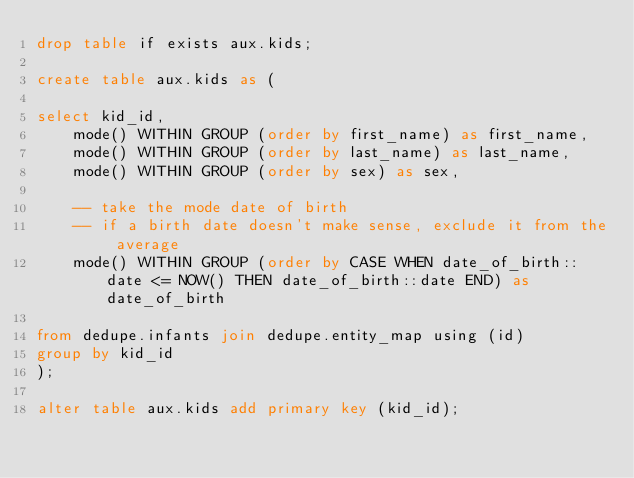Convert code to text. <code><loc_0><loc_0><loc_500><loc_500><_SQL_>drop table if exists aux.kids;

create table aux.kids as (

select kid_id, 
    mode() WITHIN GROUP (order by first_name) as first_name, 
    mode() WITHIN GROUP (order by last_name) as last_name,
    mode() WITHIN GROUP (order by sex) as sex,

    -- take the mode date of birth
    -- if a birth date doesn't make sense, exclude it from the average
    mode() WITHIN GROUP (order by CASE WHEN date_of_birth::date <= NOW() THEN date_of_birth::date END) as date_of_birth

from dedupe.infants join dedupe.entity_map using (id)
group by kid_id
);

alter table aux.kids add primary key (kid_id);
</code> 